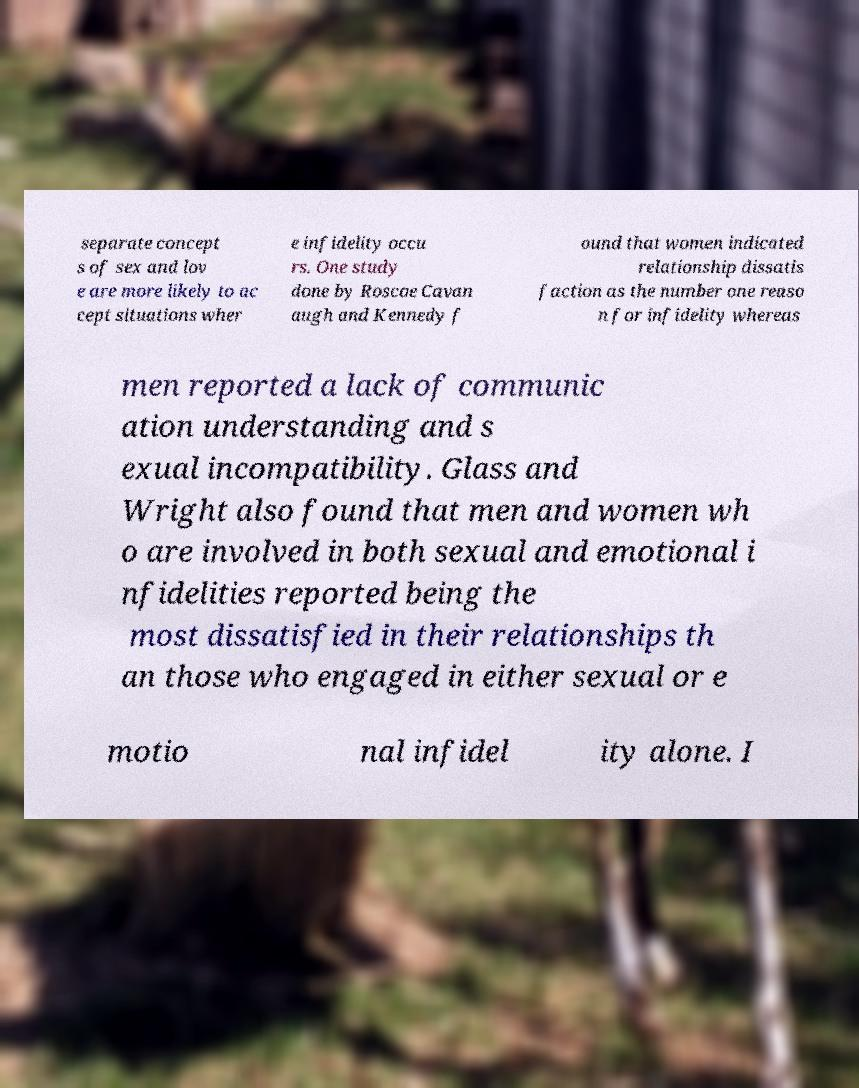I need the written content from this picture converted into text. Can you do that? separate concept s of sex and lov e are more likely to ac cept situations wher e infidelity occu rs. One study done by Roscoe Cavan augh and Kennedy f ound that women indicated relationship dissatis faction as the number one reaso n for infidelity whereas men reported a lack of communic ation understanding and s exual incompatibility. Glass and Wright also found that men and women wh o are involved in both sexual and emotional i nfidelities reported being the most dissatisfied in their relationships th an those who engaged in either sexual or e motio nal infidel ity alone. I 